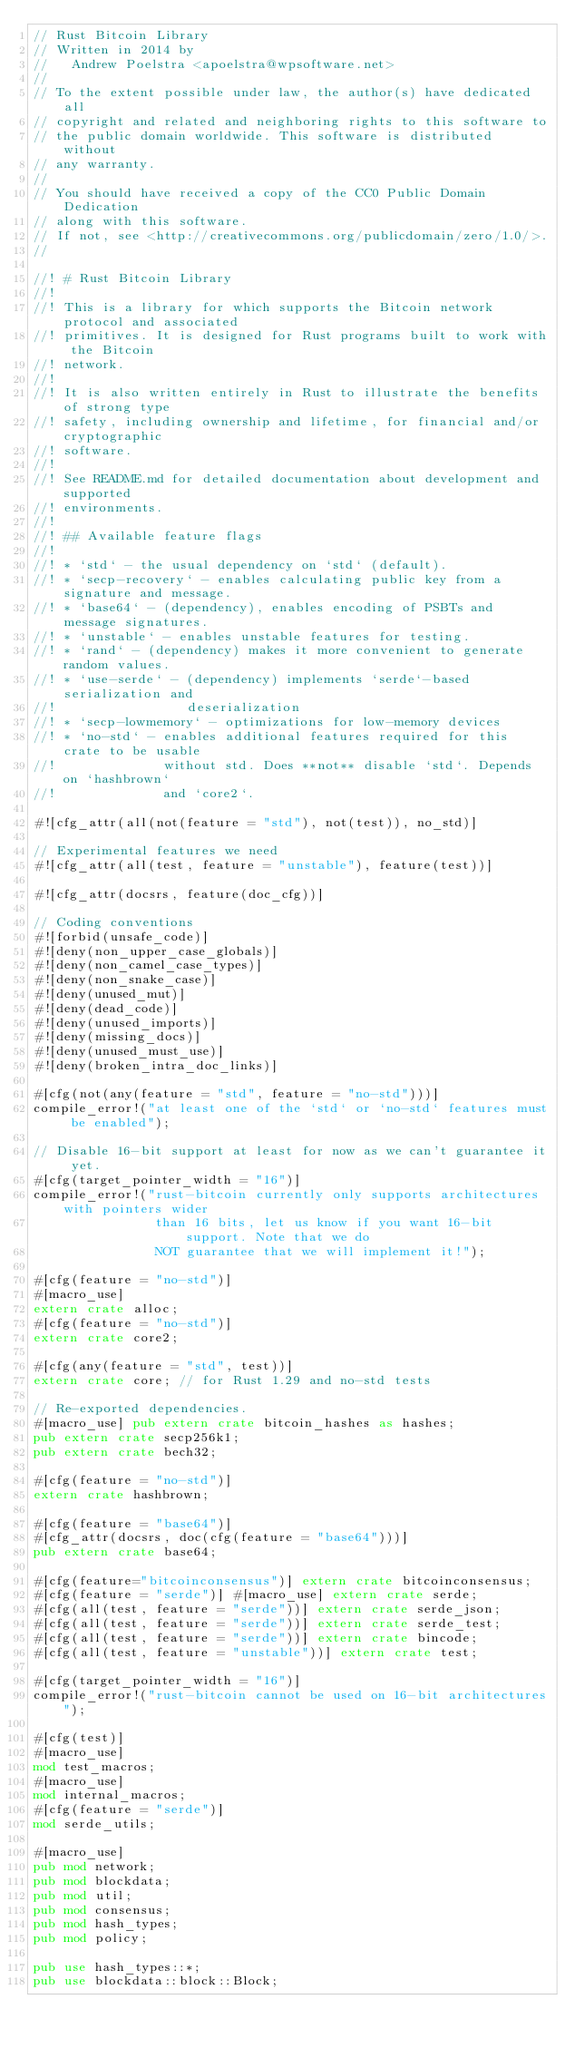<code> <loc_0><loc_0><loc_500><loc_500><_Rust_>// Rust Bitcoin Library
// Written in 2014 by
//   Andrew Poelstra <apoelstra@wpsoftware.net>
//
// To the extent possible under law, the author(s) have dedicated all
// copyright and related and neighboring rights to this software to
// the public domain worldwide. This software is distributed without
// any warranty.
//
// You should have received a copy of the CC0 Public Domain Dedication
// along with this software.
// If not, see <http://creativecommons.org/publicdomain/zero/1.0/>.
//

//! # Rust Bitcoin Library
//!
//! This is a library for which supports the Bitcoin network protocol and associated
//! primitives. It is designed for Rust programs built to work with the Bitcoin
//! network.
//!
//! It is also written entirely in Rust to illustrate the benefits of strong type
//! safety, including ownership and lifetime, for financial and/or cryptographic
//! software.
//!
//! See README.md for detailed documentation about development and supported
//! environments.
//!
//! ## Available feature flags
//!
//! * `std` - the usual dependency on `std` (default).
//! * `secp-recovery` - enables calculating public key from a signature and message.
//! * `base64` - (dependency), enables encoding of PSBTs and message signatures.
//! * `unstable` - enables unstable features for testing.
//! * `rand` - (dependency) makes it more convenient to generate random values.
//! * `use-serde` - (dependency) implements `serde`-based serialization and
//!                 deserialization
//! * `secp-lowmemory` - optimizations for low-memory devices
//! * `no-std` - enables additional features required for this crate to be usable
//!              without std. Does **not** disable `std`. Depends on `hashbrown`
//!              and `core2`.

#![cfg_attr(all(not(feature = "std"), not(test)), no_std)]

// Experimental features we need
#![cfg_attr(all(test, feature = "unstable"), feature(test))]

#![cfg_attr(docsrs, feature(doc_cfg))]

// Coding conventions
#![forbid(unsafe_code)]
#![deny(non_upper_case_globals)]
#![deny(non_camel_case_types)]
#![deny(non_snake_case)]
#![deny(unused_mut)]
#![deny(dead_code)]
#![deny(unused_imports)]
#![deny(missing_docs)]
#![deny(unused_must_use)]
#![deny(broken_intra_doc_links)]

#[cfg(not(any(feature = "std", feature = "no-std")))]
compile_error!("at least one of the `std` or `no-std` features must be enabled");

// Disable 16-bit support at least for now as we can't guarantee it yet.
#[cfg(target_pointer_width = "16")]
compile_error!("rust-bitcoin currently only supports architectures with pointers wider
                than 16 bits, let us know if you want 16-bit support. Note that we do
                NOT guarantee that we will implement it!");

#[cfg(feature = "no-std")]
#[macro_use]
extern crate alloc;
#[cfg(feature = "no-std")]
extern crate core2;

#[cfg(any(feature = "std", test))]
extern crate core; // for Rust 1.29 and no-std tests

// Re-exported dependencies.
#[macro_use] pub extern crate bitcoin_hashes as hashes;
pub extern crate secp256k1;
pub extern crate bech32;

#[cfg(feature = "no-std")]
extern crate hashbrown;

#[cfg(feature = "base64")]
#[cfg_attr(docsrs, doc(cfg(feature = "base64")))]
pub extern crate base64;

#[cfg(feature="bitcoinconsensus")] extern crate bitcoinconsensus;
#[cfg(feature = "serde")] #[macro_use] extern crate serde;
#[cfg(all(test, feature = "serde"))] extern crate serde_json;
#[cfg(all(test, feature = "serde"))] extern crate serde_test;
#[cfg(all(test, feature = "serde"))] extern crate bincode;
#[cfg(all(test, feature = "unstable"))] extern crate test;

#[cfg(target_pointer_width = "16")]
compile_error!("rust-bitcoin cannot be used on 16-bit architectures");

#[cfg(test)]
#[macro_use]
mod test_macros;
#[macro_use]
mod internal_macros;
#[cfg(feature = "serde")]
mod serde_utils;

#[macro_use]
pub mod network;
pub mod blockdata;
pub mod util;
pub mod consensus;
pub mod hash_types;
pub mod policy;

pub use hash_types::*;
pub use blockdata::block::Block;</code> 